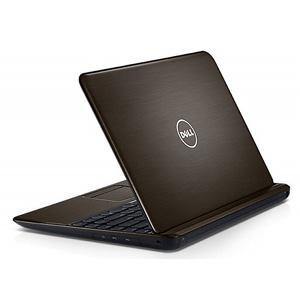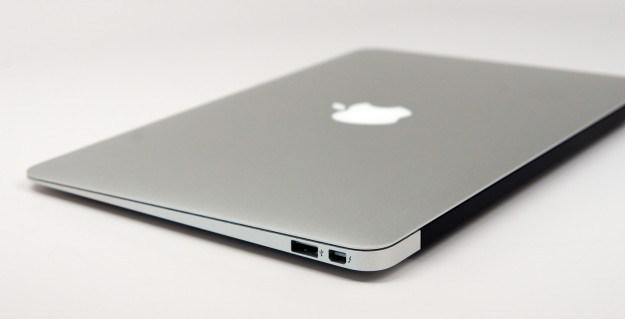The first image is the image on the left, the second image is the image on the right. Assess this claim about the two images: "There is only one laptop screen visible out of two laptops.". Correct or not? Answer yes or no. No. The first image is the image on the left, the second image is the image on the right. Evaluate the accuracy of this statement regarding the images: "All laptops are at least partly open, but only one laptop is displayed with its screen visible.". Is it true? Answer yes or no. No. 